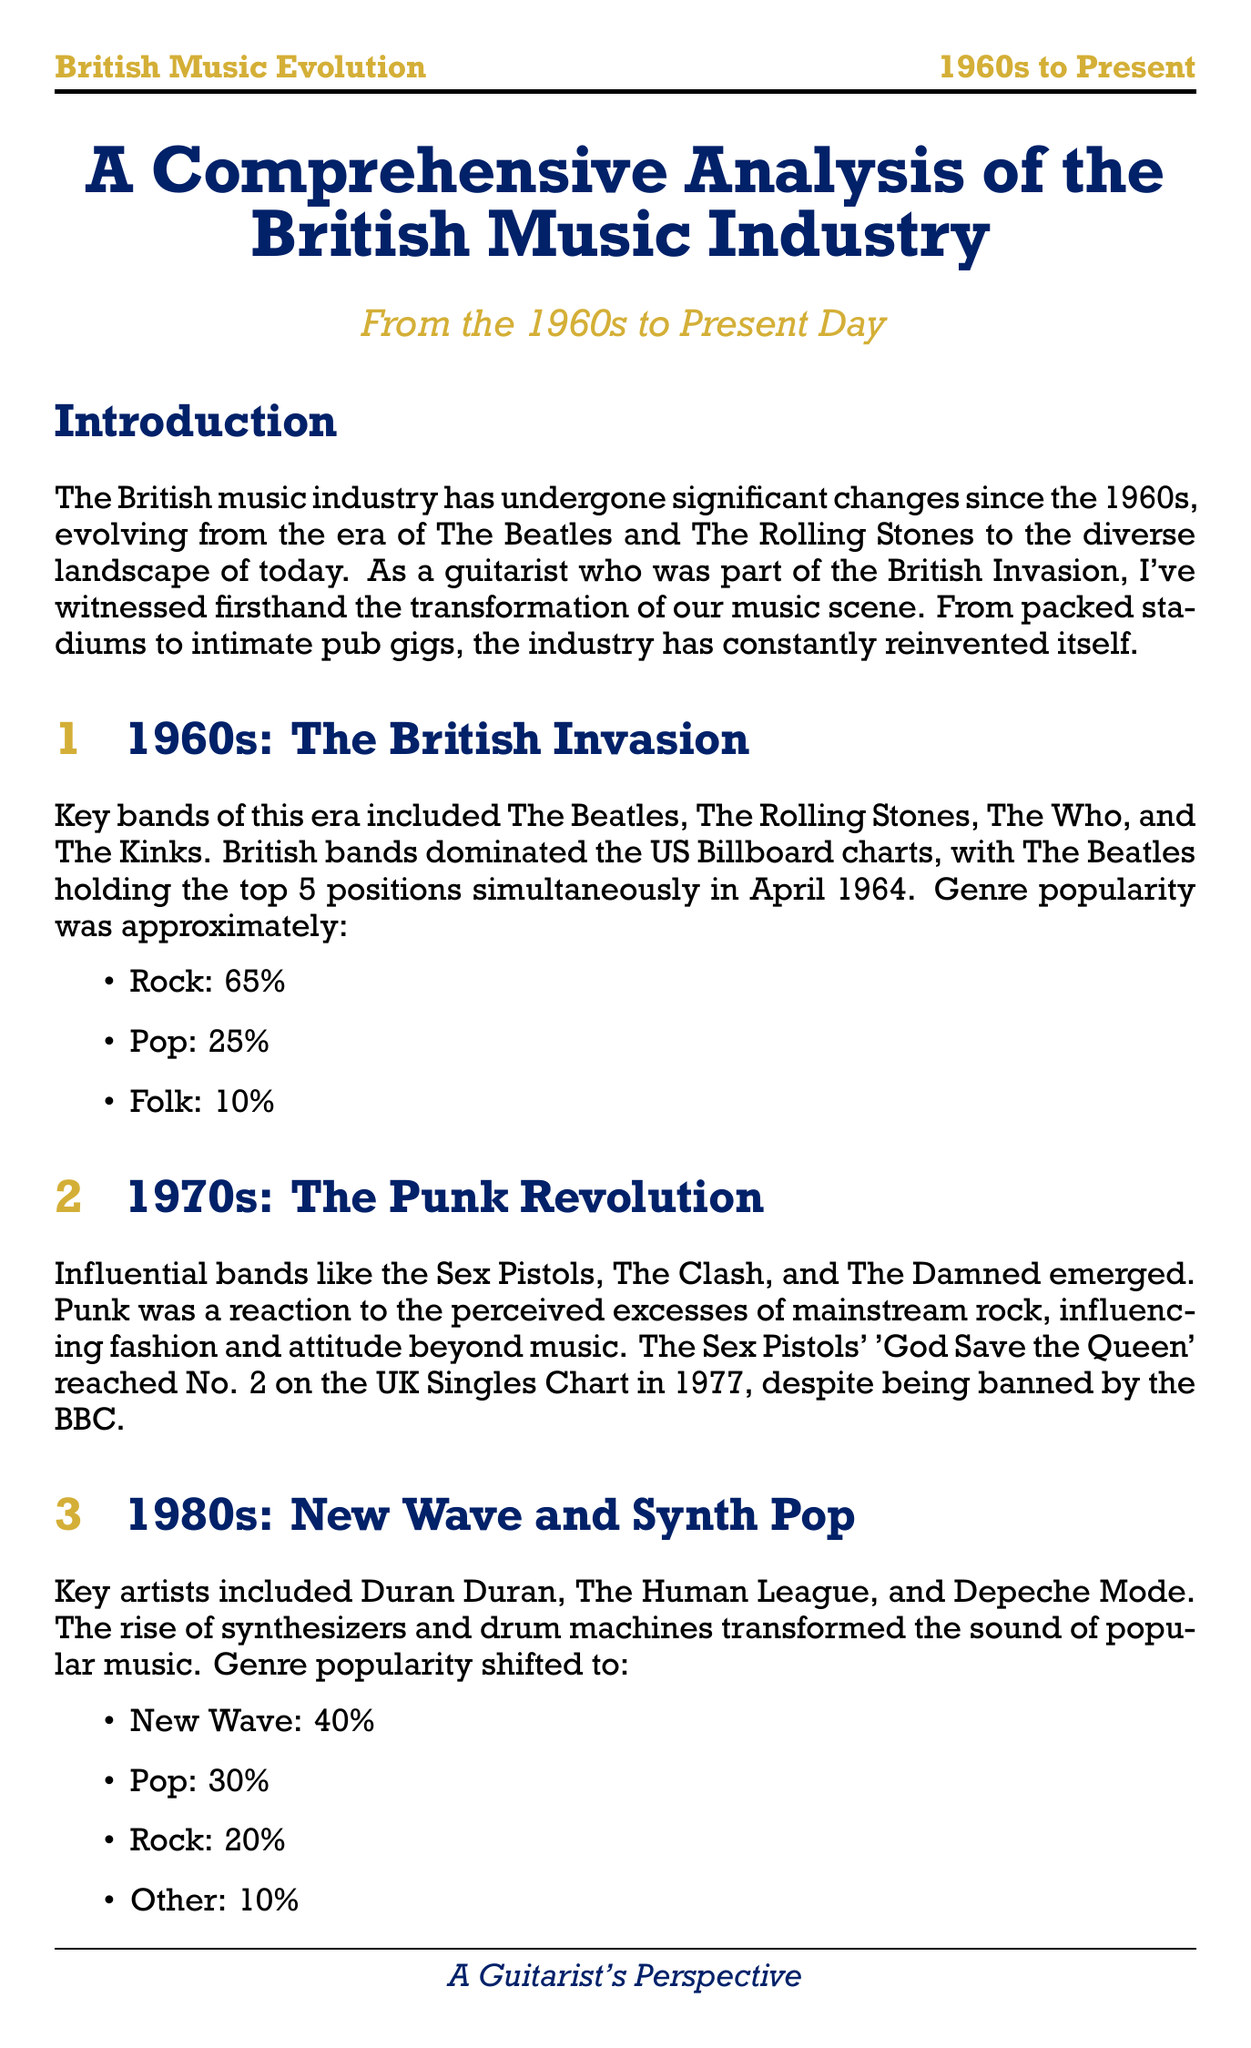what percentage of genre popularity did rock have in the 1960s? The document states that rock accounted for 65% of genre popularity in the 1960s.
Answer: 65% which band reached No. 2 on the UK Singles Chart in 1977? The Sex Pistols' 'God Save the Queen' reached No. 2 on the UK Singles Chart in 1977.
Answer: The Sex Pistols who were the key artists of the 1980s? Duran Duran, The Human League, and Depeche Mode are noted as key artists from the 1980s.
Answer: Duran Duran, The Human League, Depeche Mode what was the market value of the UK recorded music market in 2020? The document indicates that the UK recorded music market was worth £1.1 billion in 2020.
Answer: £1.1 billion which era was characterized by the rise of synthesizers and drum machines? The 1980s is identified in the document as the era of new wave and synth pop, characterized by these technological advancements.
Answer: 1980s what percentage of UK music consumption was accounted for by streaming in 2021? The document mentions that in 2021, streaming accounted for 83% of UK music consumption.
Answer: 83% which genre was the most popular in the 2000s? The document indicates that indie rock accounted for 35% of genre popularity in the 2000s, making it the most popular genre.
Answer: Indie Rock what major change occurred in the music industry during the 2000s? The rise of digital downloads and streaming platforms dramatically altered music consumption and distribution.
Answer: Digital revolution what are the notable acts mentioned in the 2000s? Arctic Monkeys, The Libertines, and Franz Ferdinand are listed as notable acts during this decade.
Answer: Arctic Monkeys, The Libertines, Franz Ferdinand 